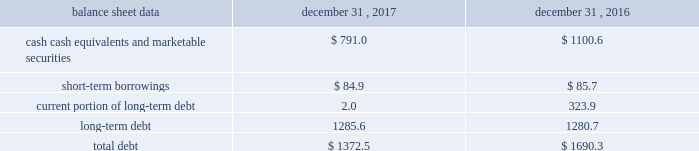Management 2019s discussion and analysis of financial condition and results of operations 2013 ( continued ) ( amounts in millions , except per share amounts ) the effect of foreign exchange rate changes on cash , cash equivalents and restricted cash included in the consolidated statements of cash flows resulted in an increase of $ 11.6 in 2016 , primarily a result of the brazilian real strengthening against the u.s .
Dollar as of december 31 , 2016 compared to december 31 , 2015. .
Liquidity outlook we expect our cash flow from operations and existing cash and cash equivalents to be sufficient to meet our anticipated operating requirements at a minimum for the next twelve months .
We also have a committed corporate credit facility , uncommitted lines of credit and a commercial paper program available to support our operating needs .
We continue to maintain a disciplined approach to managing liquidity , with flexibility over significant uses of cash , including our capital expenditures , cash used for new acquisitions , our common stock repurchase program and our common stock dividends .
From time to time , we evaluate market conditions and financing alternatives for opportunities to raise additional funds or otherwise improve our liquidity profile , enhance our financial flexibility and manage market risk .
Our ability to access the capital markets depends on a number of factors , which include those specific to us , such as our credit ratings , and those related to the financial markets , such as the amount or terms of available credit .
There can be no guarantee that we would be able to access new sources of liquidity , or continue to access existing sources of liquidity , on commercially reasonable terms , or at all .
Funding requirements our most significant funding requirements include our operations , non-cancelable operating lease obligations , capital expenditures , acquisitions , common stock dividends , taxes and debt service .
Additionally , we may be required to make payments to minority shareholders in certain subsidiaries if they exercise their options to sell us their equity interests .
Notable funding requirements include : 2022 debt service 2013 as of december 31 , 2017 , we had outstanding short-term borrowings of $ 84.9 from our uncommitted lines of credit used primarily to fund seasonal working capital needs .
The remainder of our debt is primarily long-term , with maturities scheduled through 2024 .
See the table below for the maturity schedule of our long-term debt .
2022 acquisitions 2013 we paid cash of $ 29.7 , net of cash acquired of $ 7.1 , for acquisitions completed in 2017 .
We also paid $ 0.9 in up-front payments and $ 100.8 in deferred payments for prior-year acquisitions as well as ownership increases in our consolidated subsidiaries .
In addition to potential cash expenditures for new acquisitions , we expect to pay approximately $ 42.0 in 2018 related to prior acquisitions .
We may also be required to pay approximately $ 33.0 in 2018 related to put options held by minority shareholders if exercised .
We will continue to evaluate strategic opportunities to grow and continue to strengthen our market position , particularly in our digital and marketing services offerings , and to expand our presence in high-growth and key strategic world markets .
2022 dividends 2013 during 2017 , we paid four quarterly cash dividends of $ 0.18 per share on our common stock , which corresponded to aggregate dividend payments of $ 280.3 .
On february 14 , 2018 , we announced that our board of directors ( the 201cboard 201d ) had declared a common stock cash dividend of $ 0.21 per share , payable on march 15 , 2018 to holders of record as of the close of business on march 1 , 2018 .
Assuming we pay a quarterly dividend of $ 0.21 per share and there is no significant change in the number of outstanding shares as of december 31 , 2017 , we would expect to pay approximately $ 320.0 over the next twelve months. .
What is the outstanding number of shares as of december 31 , 2017? 
Computations: (((320.0 - 1000000) / 4) / 0.21)
Answer: -1190095.2381. Management 2019s discussion and analysis of financial condition and results of operations 2013 ( continued ) ( amounts in millions , except per share amounts ) the effect of foreign exchange rate changes on cash , cash equivalents and restricted cash included in the consolidated statements of cash flows resulted in an increase of $ 11.6 in 2016 , primarily a result of the brazilian real strengthening against the u.s .
Dollar as of december 31 , 2016 compared to december 31 , 2015. .
Liquidity outlook we expect our cash flow from operations and existing cash and cash equivalents to be sufficient to meet our anticipated operating requirements at a minimum for the next twelve months .
We also have a committed corporate credit facility , uncommitted lines of credit and a commercial paper program available to support our operating needs .
We continue to maintain a disciplined approach to managing liquidity , with flexibility over significant uses of cash , including our capital expenditures , cash used for new acquisitions , our common stock repurchase program and our common stock dividends .
From time to time , we evaluate market conditions and financing alternatives for opportunities to raise additional funds or otherwise improve our liquidity profile , enhance our financial flexibility and manage market risk .
Our ability to access the capital markets depends on a number of factors , which include those specific to us , such as our credit ratings , and those related to the financial markets , such as the amount or terms of available credit .
There can be no guarantee that we would be able to access new sources of liquidity , or continue to access existing sources of liquidity , on commercially reasonable terms , or at all .
Funding requirements our most significant funding requirements include our operations , non-cancelable operating lease obligations , capital expenditures , acquisitions , common stock dividends , taxes and debt service .
Additionally , we may be required to make payments to minority shareholders in certain subsidiaries if they exercise their options to sell us their equity interests .
Notable funding requirements include : 2022 debt service 2013 as of december 31 , 2017 , we had outstanding short-term borrowings of $ 84.9 from our uncommitted lines of credit used primarily to fund seasonal working capital needs .
The remainder of our debt is primarily long-term , with maturities scheduled through 2024 .
See the table below for the maturity schedule of our long-term debt .
2022 acquisitions 2013 we paid cash of $ 29.7 , net of cash acquired of $ 7.1 , for acquisitions completed in 2017 .
We also paid $ 0.9 in up-front payments and $ 100.8 in deferred payments for prior-year acquisitions as well as ownership increases in our consolidated subsidiaries .
In addition to potential cash expenditures for new acquisitions , we expect to pay approximately $ 42.0 in 2018 related to prior acquisitions .
We may also be required to pay approximately $ 33.0 in 2018 related to put options held by minority shareholders if exercised .
We will continue to evaluate strategic opportunities to grow and continue to strengthen our market position , particularly in our digital and marketing services offerings , and to expand our presence in high-growth and key strategic world markets .
2022 dividends 2013 during 2017 , we paid four quarterly cash dividends of $ 0.18 per share on our common stock , which corresponded to aggregate dividend payments of $ 280.3 .
On february 14 , 2018 , we announced that our board of directors ( the 201cboard 201d ) had declared a common stock cash dividend of $ 0.21 per share , payable on march 15 , 2018 to holders of record as of the close of business on march 1 , 2018 .
Assuming we pay a quarterly dividend of $ 0.21 per share and there is no significant change in the number of outstanding shares as of december 31 , 2017 , we would expect to pay approximately $ 320.0 over the next twelve months. .
In 2018 , how many approximate shares would have been held for the entire year to pay the approximate $ 320 in dividends over the 12 months? 
Rationale: quarterly payments = 4 payments per year
Computations: (320 / (0.21 * 4))
Answer: 380.95238. 